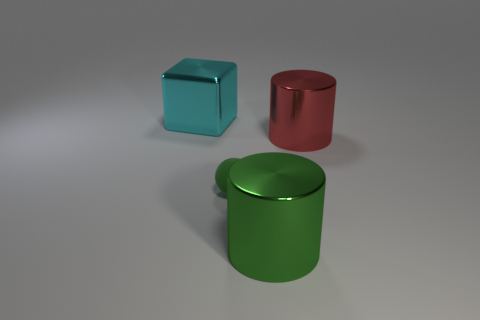Subtract all blue blocks. How many red cylinders are left? 1 Subtract all brown cylinders. Subtract all purple spheres. How many cylinders are left? 2 Subtract all small red metallic cubes. Subtract all cyan objects. How many objects are left? 3 Add 3 cyan metallic blocks. How many cyan metallic blocks are left? 4 Add 3 cylinders. How many cylinders exist? 5 Add 1 cyan rubber cylinders. How many objects exist? 5 Subtract 0 purple blocks. How many objects are left? 4 Subtract all cubes. How many objects are left? 3 